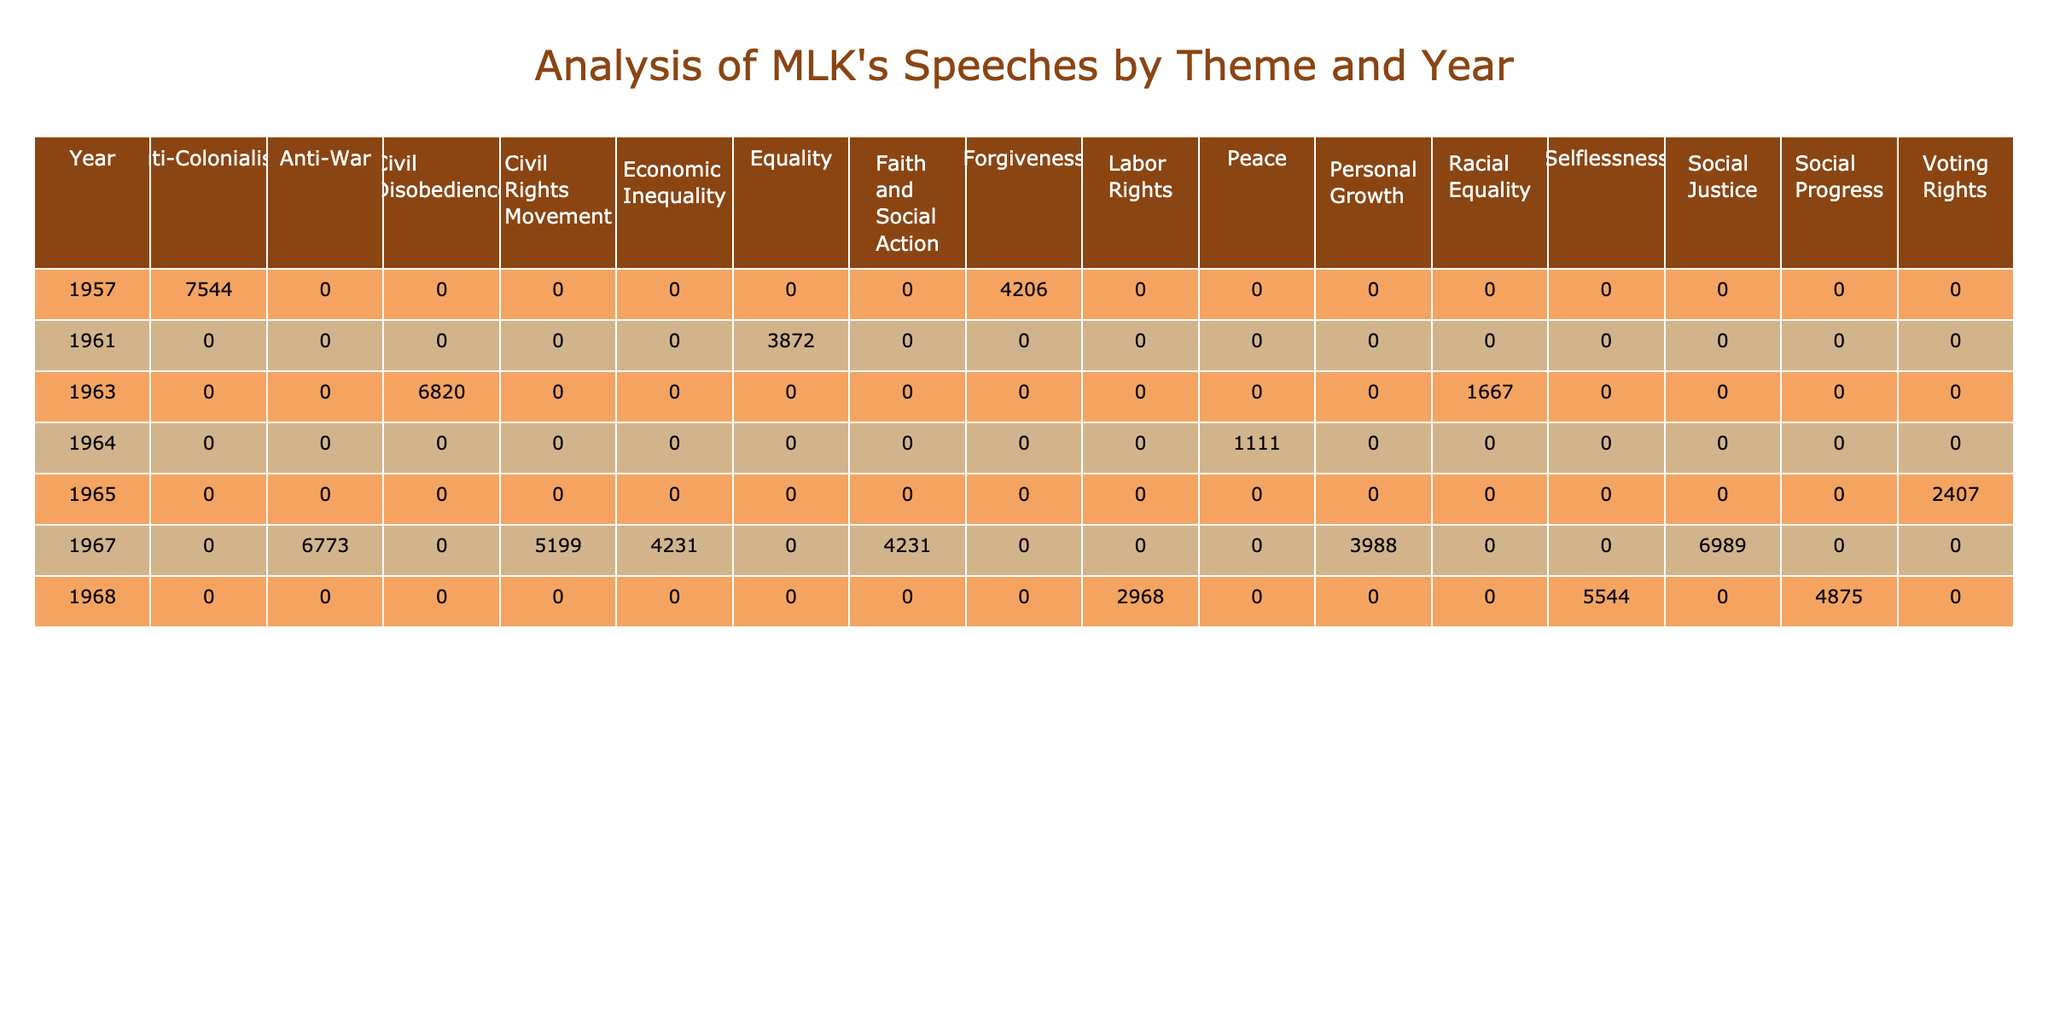What is the total word count for speeches on Racial Equality? The total word count for speeches on Racial Equality can be found by summing the word counts for the relevant speeches in the table. In 1963, "I Have a Dream" has 1667 words, and there are no other speeches related to this theme. Therefore, the total is 1667.
Answer: 1667 Which year had the highest audience size for MLK's speeches? To find the year with the highest audience size, we need to look at the audience sizes across all years. The largest audience size appears in 1963 for "I Have a Dream" with 250,000 attendees. Other years have smaller sizes.
Answer: 1963 Did Martin Luther King Jr. give a speech on Labor Rights in 1965? By checking the table, we can see that in 1965 the speech "Our God is Marching On" is listed, but it is categorized under Voting Rights, not Labor Rights. Therefore, the answer is no.
Answer: No What is the average word count of all speeches on Social Justice? The word count for the speeches classified under Social Justice is from "A Time to Break Silence" in 1967 (6989 words) and there are no other speeches for that theme. Therefore, the average is 6989/1 = 6989.
Answer: 6989 How many speeches were delivered in 1968? By examining the table, we can see there are three speeches listed in 1968: "I've Been to the Mountaintop," "The Drum Major Instinct," and "Remaining Awake Through a Great Revolution." Hence, there are 3 speeches that year.
Answer: 3 What is the total word count of the speeches in the year 1967? To calculate the total word count for 1967, we sum the word counts of all speeches from that year: "Beyond Vietnam" (6773 words), "The Other America" (4231 words), "A Time to Break Silence" (6989 words), and "Where Do We Go From Here?" (5199 words). Total = 6773 + 4231 + 6989 + 5199 = 22992.
Answer: 22992 In which theme does the speech "Loving Your Enemies" fall? Referring to the table, "Loving Your Enemies" is categorized under Forgiveness.
Answer: Forgiveness Which two years had speeches related to Economic Inequality? Reviewing the table, Economic Inequality is represented only in the year 1967 with "The Other America." Therefore, there is no second year with this theme.
Answer: 1967 only How many themes were addressed in speeches delivered in 1963? In 1963, there are two speeches: "I Have a Dream" (Racial Equality) and "Letter from Birmingham Jail" (Civil Disobedience). Therefore, there are 2 distinct themes addressed in that year.
Answer: 2 